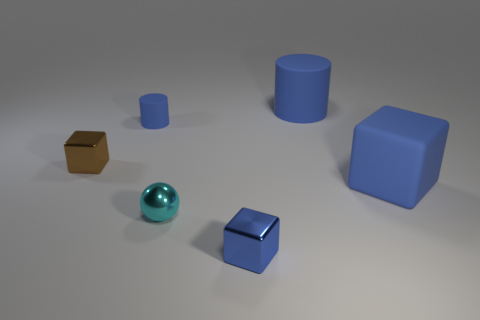There is a matte cube that is the same color as the big rubber cylinder; what is its size?
Your answer should be very brief. Large. Is the number of brown metallic blocks right of the big blue cylinder the same as the number of tiny cylinders to the right of the blue shiny block?
Your answer should be very brief. Yes. What number of other objects are there of the same size as the blue rubber block?
Provide a succinct answer. 1. What is the size of the cyan metallic object?
Keep it short and to the point. Small. Do the big blue cylinder and the tiny block right of the tiny rubber object have the same material?
Give a very brief answer. No. Is there another blue matte object that has the same shape as the small blue matte object?
Your answer should be compact. Yes. There is a sphere that is the same size as the blue metallic cube; what is it made of?
Provide a short and direct response. Metal. There is a blue cylinder to the left of the blue metal thing; what is its size?
Make the answer very short. Small. There is a block that is to the left of the ball; is its size the same as the cylinder to the left of the tiny cyan metallic ball?
Provide a succinct answer. Yes. How many tiny brown objects are made of the same material as the ball?
Give a very brief answer. 1. 